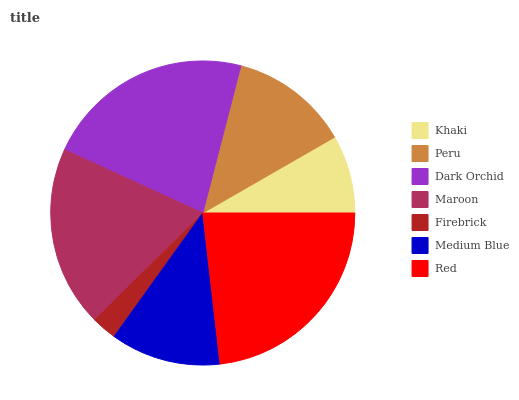Is Firebrick the minimum?
Answer yes or no. Yes. Is Red the maximum?
Answer yes or no. Yes. Is Peru the minimum?
Answer yes or no. No. Is Peru the maximum?
Answer yes or no. No. Is Peru greater than Khaki?
Answer yes or no. Yes. Is Khaki less than Peru?
Answer yes or no. Yes. Is Khaki greater than Peru?
Answer yes or no. No. Is Peru less than Khaki?
Answer yes or no. No. Is Peru the high median?
Answer yes or no. Yes. Is Peru the low median?
Answer yes or no. Yes. Is Firebrick the high median?
Answer yes or no. No. Is Red the low median?
Answer yes or no. No. 